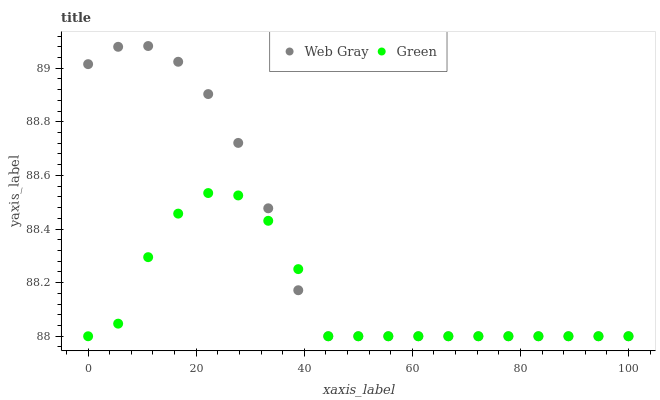Does Green have the minimum area under the curve?
Answer yes or no. Yes. Does Web Gray have the maximum area under the curve?
Answer yes or no. Yes. Does Green have the maximum area under the curve?
Answer yes or no. No. Is Web Gray the smoothest?
Answer yes or no. Yes. Is Green the roughest?
Answer yes or no. Yes. Is Green the smoothest?
Answer yes or no. No. Does Web Gray have the lowest value?
Answer yes or no. Yes. Does Web Gray have the highest value?
Answer yes or no. Yes. Does Green have the highest value?
Answer yes or no. No. Does Green intersect Web Gray?
Answer yes or no. Yes. Is Green less than Web Gray?
Answer yes or no. No. Is Green greater than Web Gray?
Answer yes or no. No. 